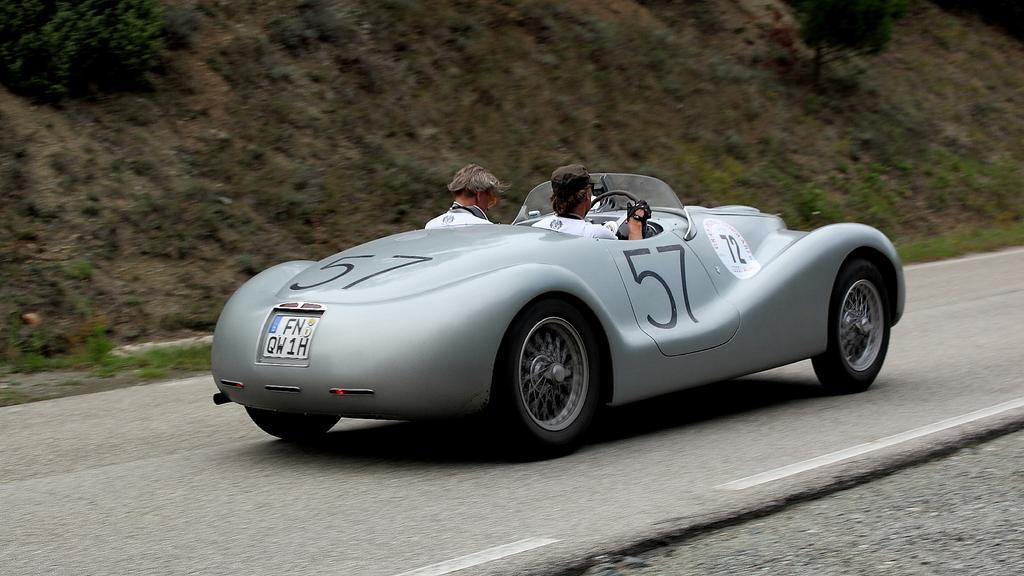In one or two sentences, can you explain what this image depicts? In this image in the center there is a car with the persons sitting in inside it moving on the road with some text written on it. In the background there are plants and there is grass. 